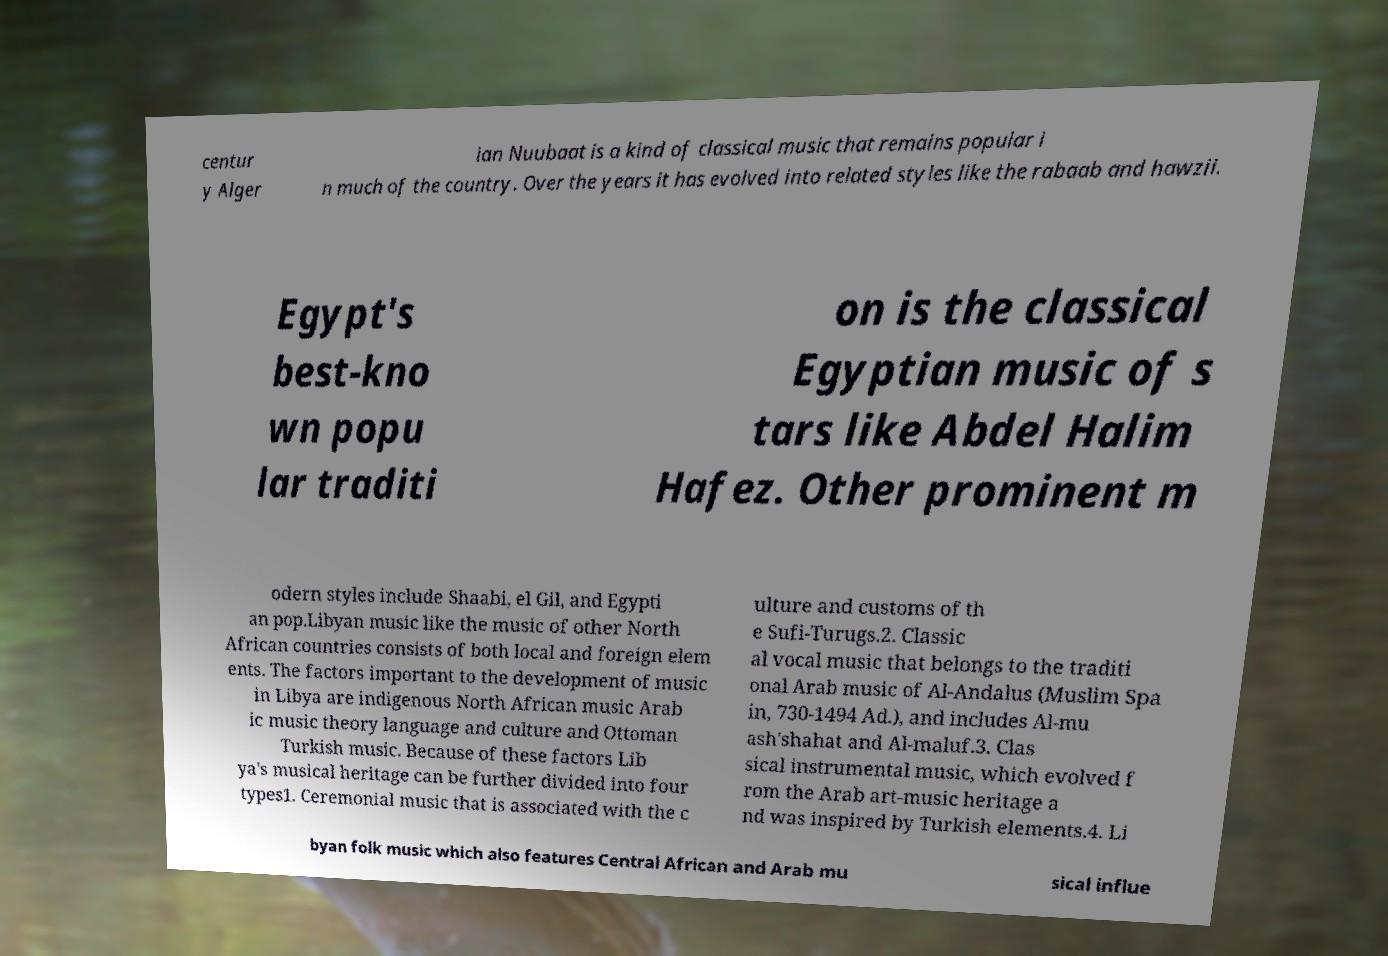Please read and relay the text visible in this image. What does it say? centur y Alger ian Nuubaat is a kind of classical music that remains popular i n much of the country. Over the years it has evolved into related styles like the rabaab and hawzii. Egypt's best-kno wn popu lar traditi on is the classical Egyptian music of s tars like Abdel Halim Hafez. Other prominent m odern styles include Shaabi, el Gil, and Egypti an pop.Libyan music like the music of other North African countries consists of both local and foreign elem ents. The factors important to the development of music in Libya are indigenous North African music Arab ic music theory language and culture and Ottoman Turkish music. Because of these factors Lib ya's musical heritage can be further divided into four types1. Ceremonial music that is associated with the c ulture and customs of th e Sufi-Turugs.2. Classic al vocal music that belongs to the traditi onal Arab music of Al-Andalus (Muslim Spa in, 730-1494 Ad.), and includes Al-mu ash'shahat and Al-maluf.3. Clas sical instrumental music, which evolved f rom the Arab art-music heritage a nd was inspired by Turkish elements.4. Li byan folk music which also features Central African and Arab mu sical influe 